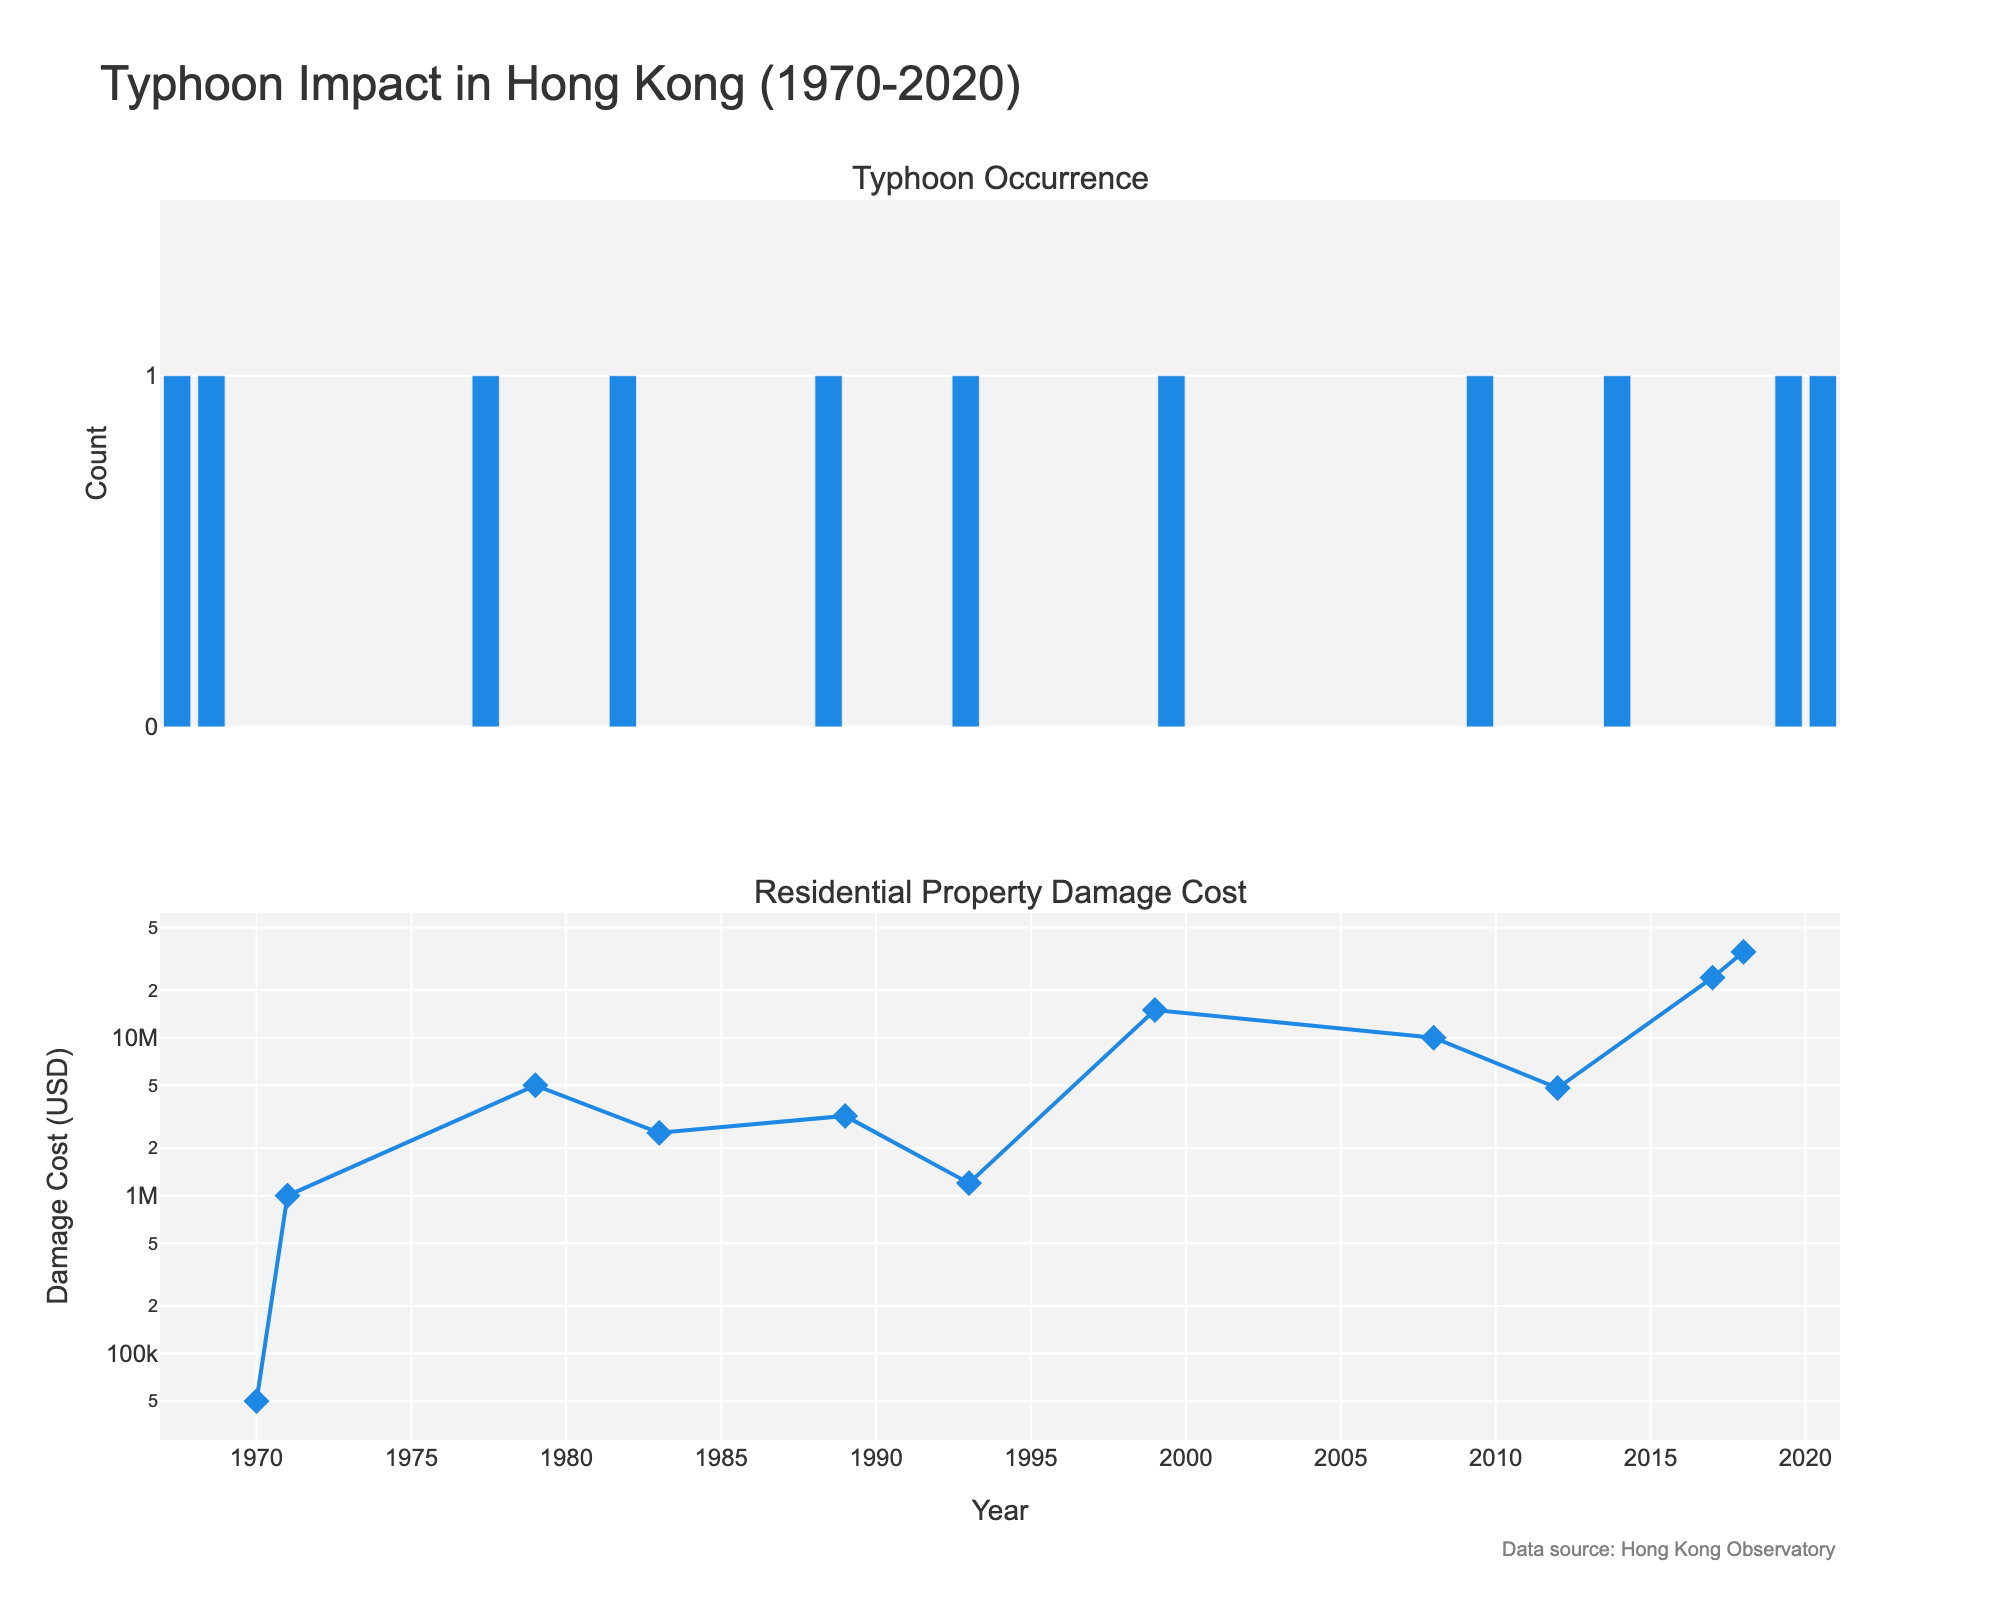What is the title of the figure? The title is located at the top center of the figure. The text of the title is "Typhoon Impact in Hong Kong (1970-2020)".
Answer: Typhoon Impact in Hong Kong (1970-2020) How many typhoons are represented in the figure? Count the number of bars in the top subplot or the number of data points in the bottom subplot. There are 11 typhoons.
Answer: 11 What does the y-axis represent in the bottom subplot? The y-axis title in the bottom subplot is "Damage Cost (USD)", and it uses a logarithmic scale. This means it represents the residential property damage cost due to typhoons in USD on a log scale.
Answer: Damage Cost (USD) Which typhoon caused the highest residential property damage cost in USD? Looking at the highest point on the scatter plot in the bottom subplot, the year is 2018, which corresponds to Typhoon Mangkhut with a damage cost of $35,000,000.
Answer: Typhoon Mangkhut What is the damage cost in USD of Typhoon Hope? Find the data point for the year 1979 in the bottom subplot. The y-value, plotted on the logarithmic scale, shows a damage cost of $5,000,000.
Answer: $5,000,000 In which year was there a significant increase in damage costs compared to the previous year? Compare the y-values of consecutive data points in the bottom subplot. From 2017 to 2018, the damage cost surged from $24,000,000 to $35,000,000, indicating a significant increase.
Answer: 2018 Which typhoon, after 1999, had the highest recorded residential property damage cost? Examine the scatter plot for data points after 1999. The 2018 point (Typhoon Mangkhut) has the highest value, $35,000,000.
Answer: Typhoon Mangkhut How often do typhoons hit Hong Kong based on the figure? Look at the x-axis intervals in the top subplot. Spacing between bars (years with typhoons) indicates that typhoons occur roughly every few years, but with irregular intervals.
Answer: Roughly every few years What is the range of residential property damage costs recorded in the plot? Identify the minimum and maximum y-values in the bottom subplot. The range starts from the smallest damage cost ($50,000 in 1970) to the highest ($35,000,000 in 2018).
Answer: $50,000 to $35,000,000 What can you infer about the trend in residential property damage costs from 1970 to 2020? Observing the scatter plot in the bottom subplot, there seems to be an increasing trend in damage costs over the years, with notable peaks in 1999, 2017, and 2018.
Answer: Increasing trend 